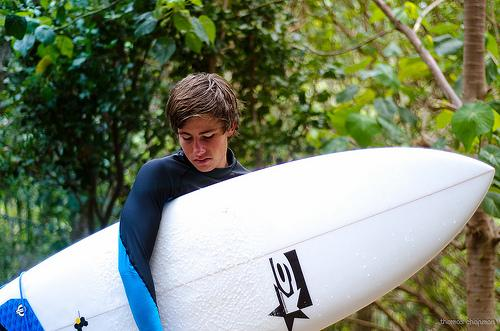Evaluate the quality of the image regarding the details it provides. The image quality is good, as it provides clear details of the surfer, his wetsuit, the surfboard, and the background. Provide a brief description of the surfboard's appearance, including its color and any visible design. The surfboard is white with a black emblem, a blue design on the rear, and a brown line down the center. What does the surfer look like in terms of hair color and age? The surfer has brown hair, and appears to be young. How is the person holding the surfboard and what is the color of his wetsuit? The person is holding the surfboard under his arm, and he is wearing a two-toned blue wetsuit. Count the number of different features on the surfboard that have been identified. There are at least 8 different features identified on the surfboard. Describe the interaction between the surfer and his surfboard. The surfer is holding the white surfboard under his arm, and the blue cord attached to the board is hanging on one side. Analyze the composition and arrangement of objects in the image, focusing on how the image elements contribute to a complex reasoning task. The composition of the image, including the surfer with his wetsuit and surfboard, trees in the background, and visible sun, invites viewers to consider the scene's surfing context and the potential risk-reward relationship the surfer experiences during his activity. Based on the image, what sentiment can be associated with the surfer's activity? The sentiment associated with the image is likely to be excitement or anticipation for surfing. Mention any noteworthy elements of the background in the image. There are green, leafy trees with large leaves and brown trunks in the background, and the sun is shining. Describe the scene in the image. A young man in a two-toned blue wetsuit is holding a white surfboard with black markings under his arm. He has long brown hair and is looking down. A green tree with leaves and a brown trunk is in the background, and the sun is shining. Determine which caption refers to the same object as "a mark printed on the surfboard" A black and white markings on the surfboard Describe the emblem on the surfboard. The emblem is a black and white design with a small bone drawing. Is there any text visible in the image? No text visible What is the boy doing with the surfboard? The boy is carrying the surfboard under his arm. Explain how the boy interacts with the surfboard. The boy is holding the surfboard under his right arm and carrying it. Can you find the purple dolphin swimming near the boy with the surfboard? There is no mention of a purple dolphin or any swimming creature in the image, and it would be unlikely to find a dolphin near a boy with a surfboard in a non-aquatic setting. Where is the dog wearing sunglasses and a polka-dotted swimsuit? There is no mention of a dog or any animals wearing sunglasses and a swimsuit in the image, and a dog wearing such items would be quite unusual in the context of the image. Identify the different areas of the surfboard, trees, and the person. Tip of surfboard, line in the middle of surfboard, blue cord over white, black logo on white board, green leaves on tree, brown tree trunk, blue design on rear of board, blue shirt, two-toned blue wetsuit, long brown hair, facial expression of the person. Identify the objects present in the image. Guy, surfboard, wetsuit, facial expression, mark on surfboard, background trees, tip of surfboard, blue string on surfboard, black logo on white board, blue wet suit, small bone drawing, long brown hair, thick bushes, brown tree trunk, blue design on surfboard, right arm, white surf board, black design, green tree, large leaf, blue shirt, brown hair, young boy, sun, tilted tree branch, green leaves, two toned blue wetsuit, white board with black emblem, dark and light blue sleeve, line on surfboard, blue cord over white, decoration on surfboard, leafy trees, trunk. What is the primary color of the leaves on the trees in the image? Green How many trees are there in the background? There are multiple trees in the background, with thick bushes and leafy green leaves. What is the overall sentiment of the image? Positive and carefree Observe the red ball lying on the ground behind the surfer. There is no mention of a red ball lying on the ground in the image, and the focus is on the surfer and his surfboard, not on any other objects in the scene. How would you rate the quality of this image? Good quality What is the hair color of the person holding the surfboard? The hair color is brown. What color is the boy's wetsuit? Two-toned blue Take note of the rainbow-colored umbrella floating above the trees. There is no mention of a rainbow-colored umbrella or anything floating above the trees in the image, and the scene seems to be focused on the surfer and the natural elements around him. Describe the colors of the wetsuit worn by the person in the image. Two-toned blue, with dark and light blue shades Look for the woman with a large red hat sitting under the tree. There is no mention of a woman or a red hat in the image, and the focus is on a young boy carrying a surfboard, not on any other people in the scene. Is the wetsuit worn by the person black or blue? Blue Are there any unusual elements in the image? No unusual elements present. The group of people standing near the surfer is laughing and applauding his performance. There is no mention of a group of people standing near the surfer, let alone laughing or applauding, in the image, and the focus is on the young boy carrying a surfboard and his surroundings rather than any other people. Is the surfboard white or blue? The surfboard is white. 